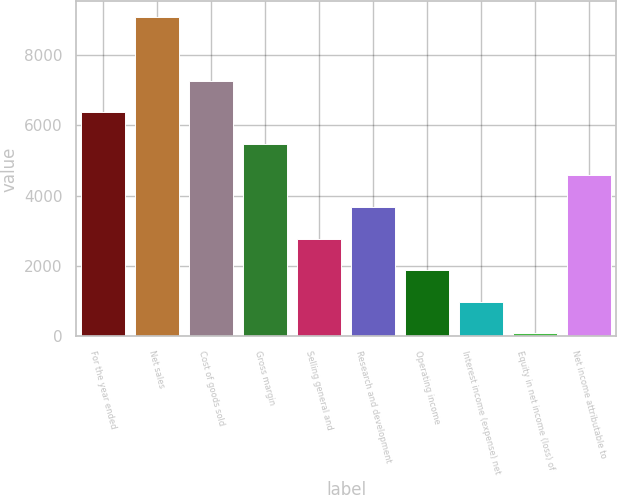<chart> <loc_0><loc_0><loc_500><loc_500><bar_chart><fcel>For the year ended<fcel>Net sales<fcel>Cost of goods sold<fcel>Gross margin<fcel>Selling general and<fcel>Research and development<fcel>Operating income<fcel>Interest income (expense) net<fcel>Equity in net income (loss) of<fcel>Net income attributable to<nl><fcel>6376<fcel>9073<fcel>7275<fcel>5477<fcel>2780<fcel>3679<fcel>1881<fcel>982<fcel>83<fcel>4578<nl></chart> 